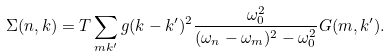<formula> <loc_0><loc_0><loc_500><loc_500>\Sigma ( n , { k } ) = T \sum _ { m { k } ^ { \prime } } g ( { k } - { k } ^ { \prime } ) ^ { 2 } \frac { \omega _ { 0 } ^ { 2 } } { ( \omega _ { n } - \omega _ { m } ) ^ { 2 } - \omega _ { 0 } ^ { 2 } } G ( m , { k } ^ { \prime } ) .</formula> 